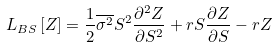Convert formula to latex. <formula><loc_0><loc_0><loc_500><loc_500>L _ { B S } \left [ Z \right ] = \frac { 1 } { 2 } \overline { \sigma ^ { 2 } } S ^ { 2 } \frac { \partial ^ { 2 } Z } { \partial S ^ { 2 } } + r S \frac { \partial Z } { \partial S } - r Z</formula> 